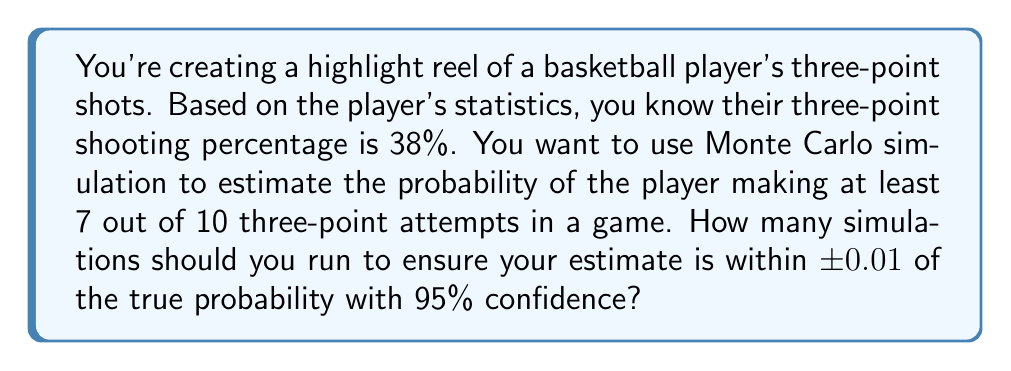Teach me how to tackle this problem. To determine the number of simulations needed, we'll use the following steps:

1. First, we need to understand that this is a binomial probability problem. The probability of success (making a three-point shot) is $p = 0.38$, and we're interested in the probability of at least 7 successes out of 10 trials.

2. The true probability can be calculated using the binomial distribution:

   $$P(X \geq 7) = \sum_{k=7}^{10} \binom{10}{k} (0.38)^k (0.62)^{10-k} \approx 0.0461$$

3. For Monte Carlo simulation, we can use the normal approximation to determine the required number of simulations. The formula is:

   $$n = \left(\frac{z_{\alpha/2} \cdot \sqrt{p(1-p)}}{E}\right)^2$$

   Where:
   - $n$ is the number of simulations
   - $z_{\alpha/2}$ is the z-score for the desired confidence level (1.96 for 95% confidence)
   - $p$ is the true probability (0.0461 in this case)
   - $E$ is the desired margin of error (0.01 in this case)

4. Plugging in the values:

   $$n = \left(\frac{1.96 \cdot \sqrt{0.0461(1-0.0461)}}{0.01}\right)^2$$

5. Calculating:

   $$n = \left(\frac{1.96 \cdot 0.2097}{0.01}\right)^2 = (41.1012)^2 = 1689.31$$

6. Since we need a whole number of simulations, we round up to the nearest integer.
Answer: 1690 simulations 